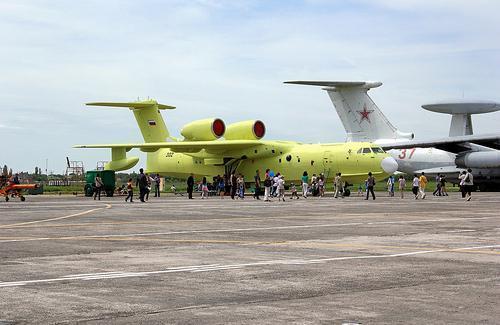How many planes are partially shown?
Give a very brief answer. 2. 